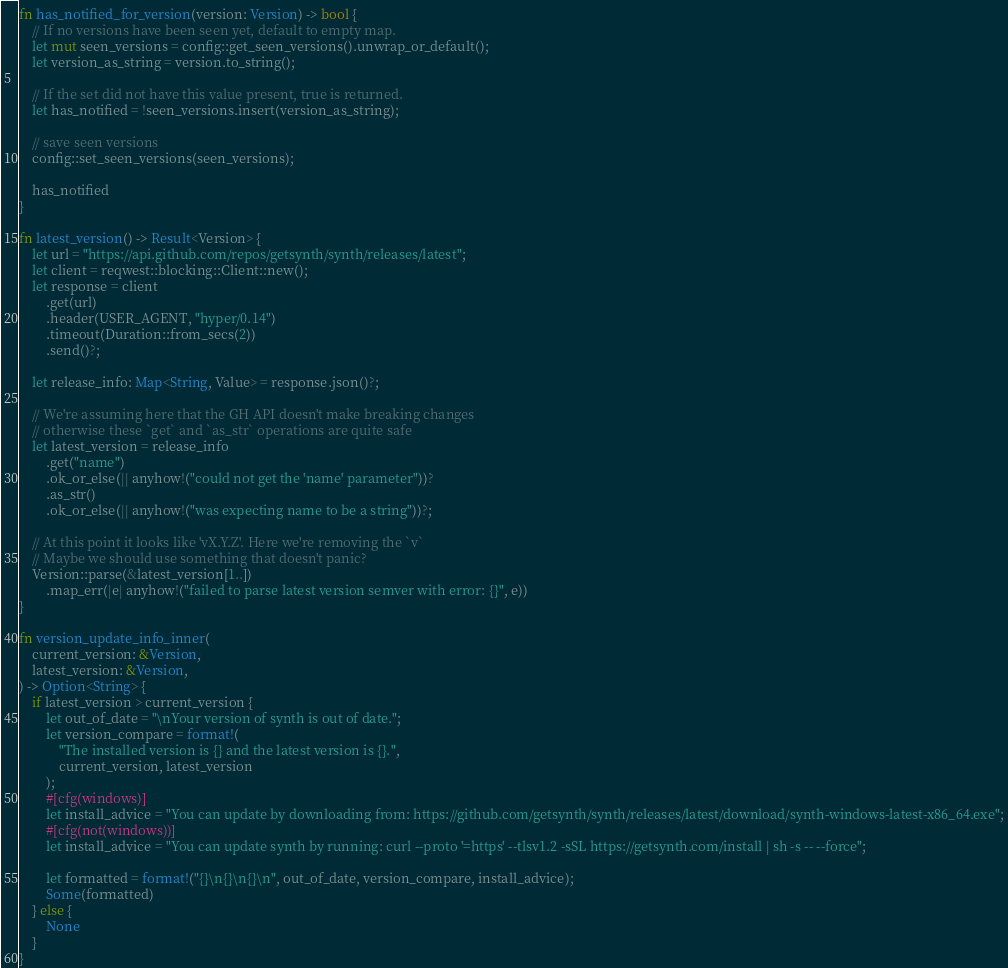Convert code to text. <code><loc_0><loc_0><loc_500><loc_500><_Rust_>
fn has_notified_for_version(version: Version) -> bool {
    // If no versions have been seen yet, default to empty map.
    let mut seen_versions = config::get_seen_versions().unwrap_or_default();
    let version_as_string = version.to_string();

    // If the set did not have this value present, true is returned.
    let has_notified = !seen_versions.insert(version_as_string);

    // save seen versions
    config::set_seen_versions(seen_versions);

    has_notified
}

fn latest_version() -> Result<Version> {
    let url = "https://api.github.com/repos/getsynth/synth/releases/latest";
    let client = reqwest::blocking::Client::new();
    let response = client
        .get(url)
        .header(USER_AGENT, "hyper/0.14")
        .timeout(Duration::from_secs(2))
        .send()?;

    let release_info: Map<String, Value> = response.json()?;

    // We're assuming here that the GH API doesn't make breaking changes
    // otherwise these `get` and `as_str` operations are quite safe
    let latest_version = release_info
        .get("name")
        .ok_or_else(|| anyhow!("could not get the 'name' parameter"))?
        .as_str()
        .ok_or_else(|| anyhow!("was expecting name to be a string"))?;

    // At this point it looks like 'vX.Y.Z'. Here we're removing the `v`
    // Maybe we should use something that doesn't panic?
    Version::parse(&latest_version[1..])
        .map_err(|e| anyhow!("failed to parse latest version semver with error: {}", e))
}

fn version_update_info_inner(
    current_version: &Version,
    latest_version: &Version,
) -> Option<String> {
    if latest_version > current_version {
        let out_of_date = "\nYour version of synth is out of date.";
        let version_compare = format!(
            "The installed version is {} and the latest version is {}.",
            current_version, latest_version
        );
        #[cfg(windows)]
        let install_advice = "You can update by downloading from: https://github.com/getsynth/synth/releases/latest/download/synth-windows-latest-x86_64.exe";
        #[cfg(not(windows))]
        let install_advice = "You can update synth by running: curl --proto '=https' --tlsv1.2 -sSL https://getsynth.com/install | sh -s -- --force";

        let formatted = format!("{}\n{}\n{}\n", out_of_date, version_compare, install_advice);
        Some(formatted)
    } else {
        None
    }
}
</code> 